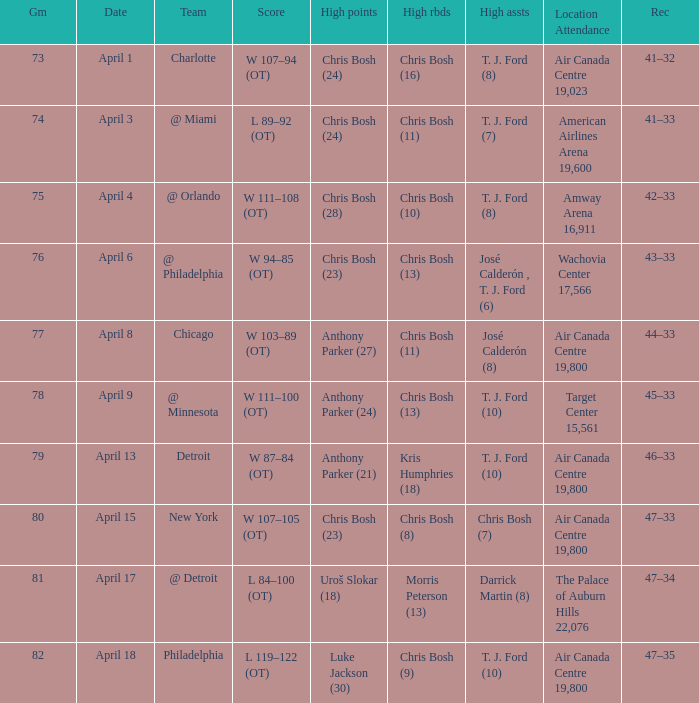What were the assists on April 8 in game less than 78? José Calderón (8). 